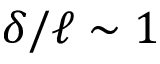Convert formula to latex. <formula><loc_0><loc_0><loc_500><loc_500>\delta / \ell \sim 1</formula> 